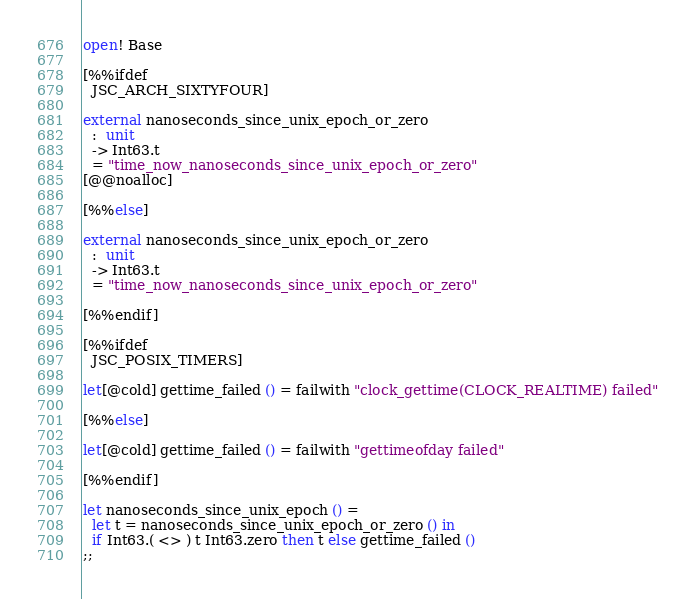<code> <loc_0><loc_0><loc_500><loc_500><_OCaml_>open! Base

[%%ifdef
  JSC_ARCH_SIXTYFOUR]

external nanoseconds_since_unix_epoch_or_zero
  :  unit
  -> Int63.t
  = "time_now_nanoseconds_since_unix_epoch_or_zero"
[@@noalloc]

[%%else]

external nanoseconds_since_unix_epoch_or_zero
  :  unit
  -> Int63.t
  = "time_now_nanoseconds_since_unix_epoch_or_zero"

[%%endif]

[%%ifdef
  JSC_POSIX_TIMERS]

let[@cold] gettime_failed () = failwith "clock_gettime(CLOCK_REALTIME) failed"

[%%else]

let[@cold] gettime_failed () = failwith "gettimeofday failed"

[%%endif]

let nanoseconds_since_unix_epoch () =
  let t = nanoseconds_since_unix_epoch_or_zero () in
  if Int63.( <> ) t Int63.zero then t else gettime_failed ()
;;
</code> 